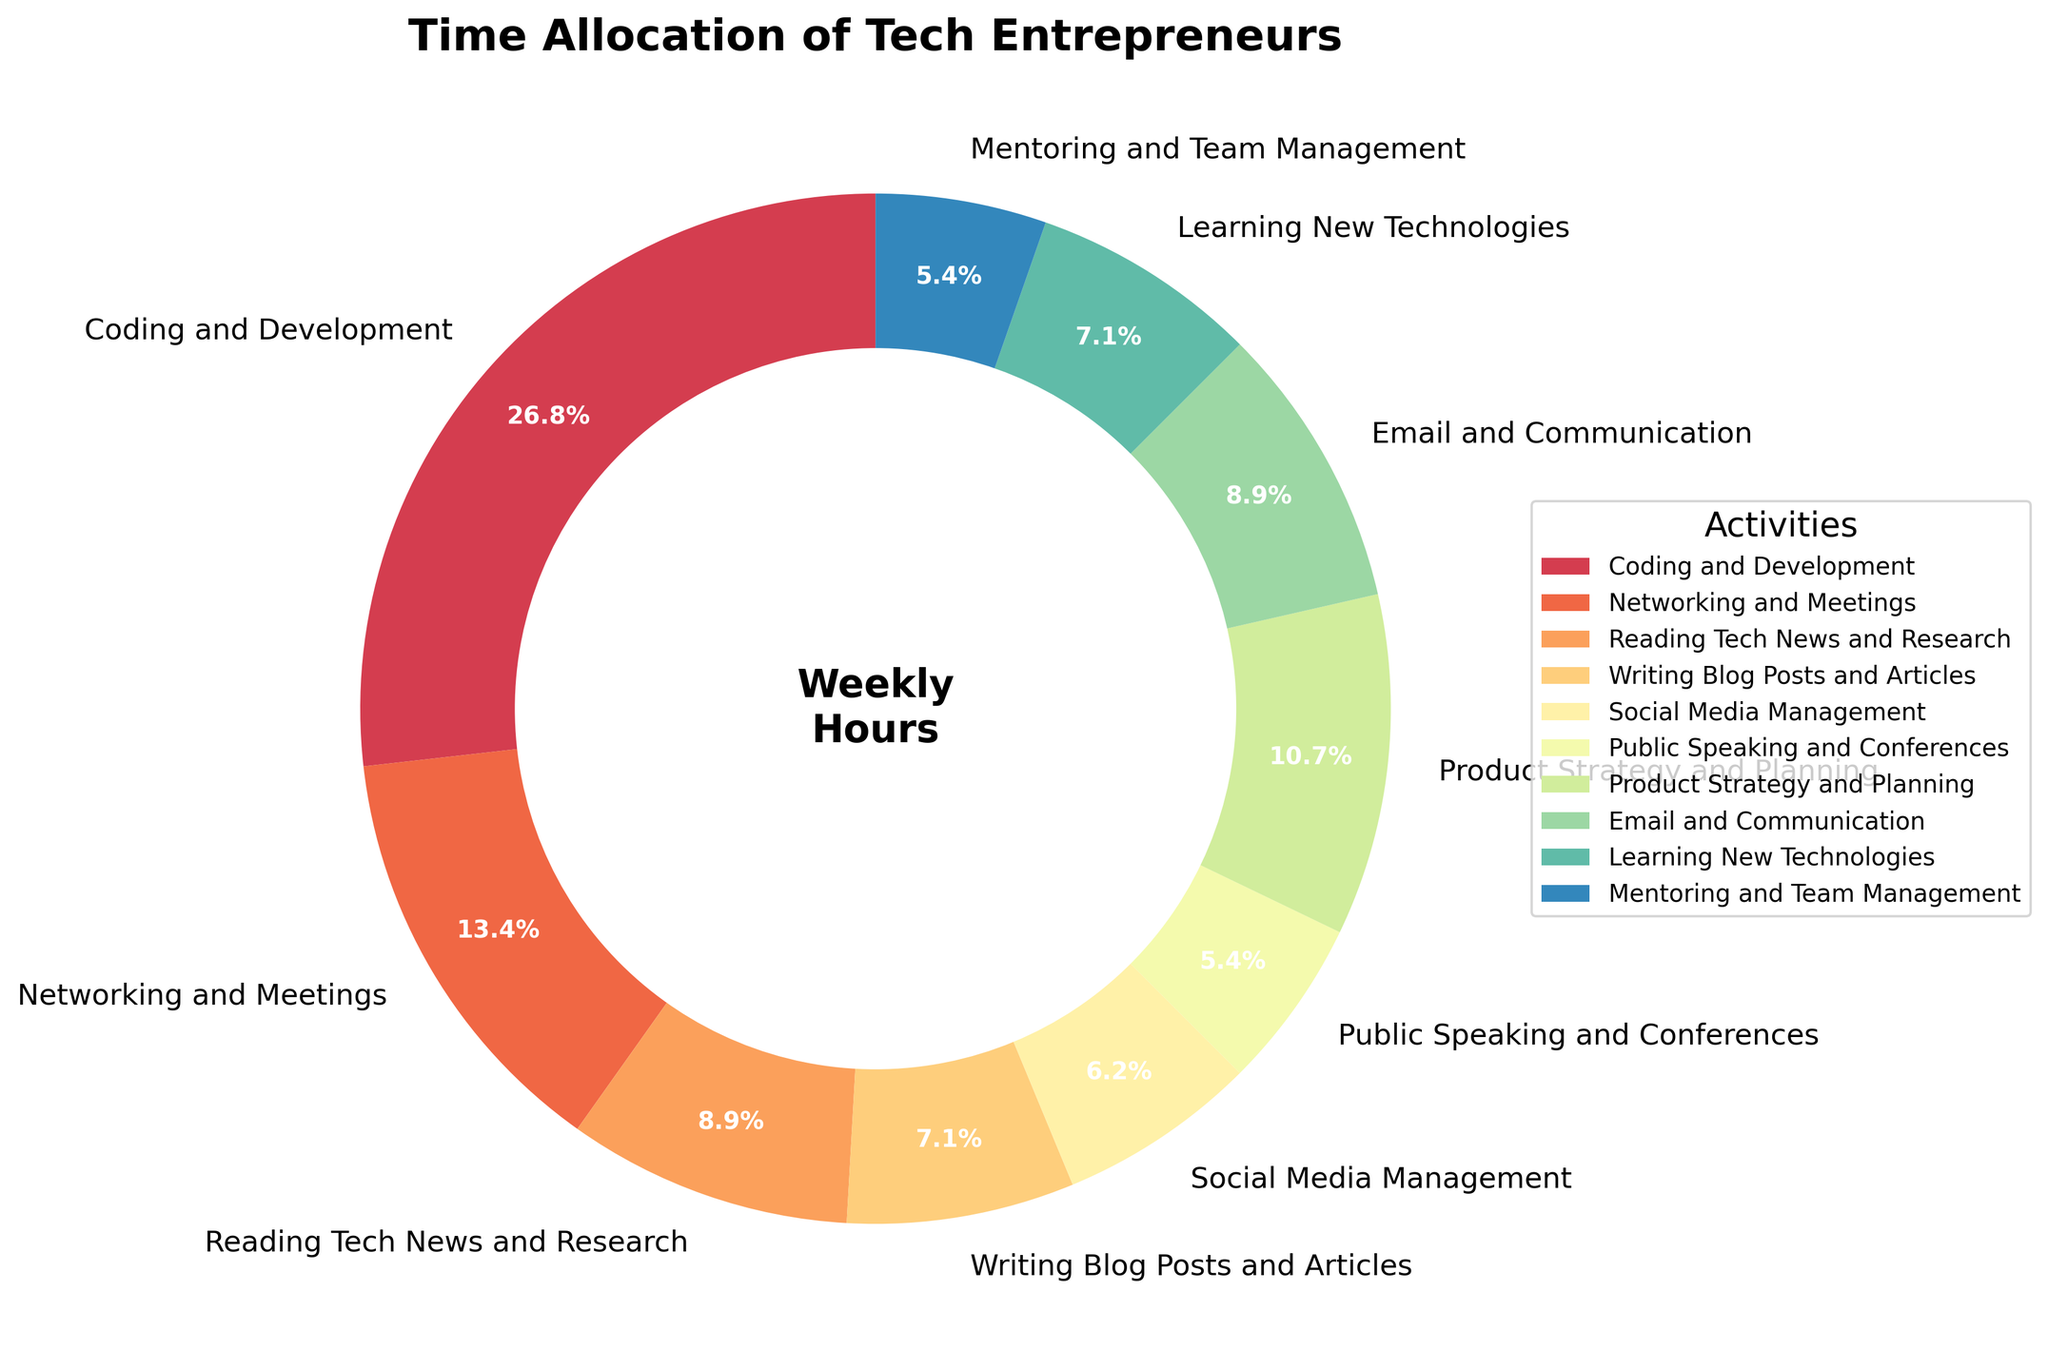What percentage of time do tech entrepreneurs spend on activities related to content creation (writing blog posts, social media management, public speaking)? First, find the percentages for writing blog posts (8 hours), social media management (7 hours), and public speaking (6 hours). The corresponding percentages are 8%, 7%, and 6%, respectively. Add them together: 8% + 7% + 6% = 21%.
Answer: 21% Which activity requires the most time? Check the figure for the activity with the largest percentage. Coding and Development is represented with the largest slice at 30%.
Answer: Coding and Development How much more time is spent on coding and development compared to writing blog posts and articles? Coding and Development takes 30 hours, while Writing Blog Posts and Articles takes 8 hours. The difference is 30 - 8 = 22 hours.
Answer: 22 hours What is the combined percentage of time spent on product strategy and planning, and email and communication? Product Strategy and Planning is at 12% and Email and Communication at 10%. Add these percentages: 12% + 10% = 22%.
Answer: 22% Which activity takes up an equal amount of time as public speaking and mentoring combined? Public Speaking and Conferences take 6 hours and Mentoring and Team Management also take 6 hours. Thus, combined they are 6 + 6 = 12 hours. The figure shows Product Strategy and Planning also at 12 hours (12%).
Answer: Product Strategy and Planning Is more time spent on reading tech news and research or learning new technologies? Check the figure for the percentage for each activity. Reading Tech News and Research is at 10% while Learning New Technologies is at 8%. 10% > 8%, so more time is spent on reading tech news and research.
Answer: Reading Tech News and Research What is the average time spent per activity? Sum the total hours spent on all activities (30 + 15 + 10 + 8 + 7 + 6 + 12 + 10 + 8 + 6 = 112 hours). There are 10 activities, so the average is 112 hours / 10 activities = 11.2 hours.
Answer: 11.2 hours How much time is spent on email and communication compared to public speaking and mentoring combined? Email and Communication takes 10 hours, while Public Speaking and Conferences and Mentoring and Team Management combined take 6 + 6 = 12 hours. The comparison shows 10 < 12.
Answer: less time Which activity uses up more time: networking and meetings or product strategy and planning? In the figure, Networking and Meetings uses 15% of the time, while Product Strategy and Planning uses 12%. 15% > 12%, so more time is spent on Networking and Meetings.
Answer: Networking and Meetings 